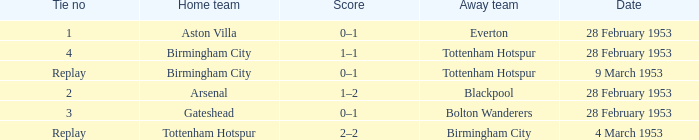Which Score has a Date of 28 february 1953, and a Tie no of 3? 0–1. 